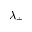Convert formula to latex. <formula><loc_0><loc_0><loc_500><loc_500>\lambda _ { \pm }</formula> 